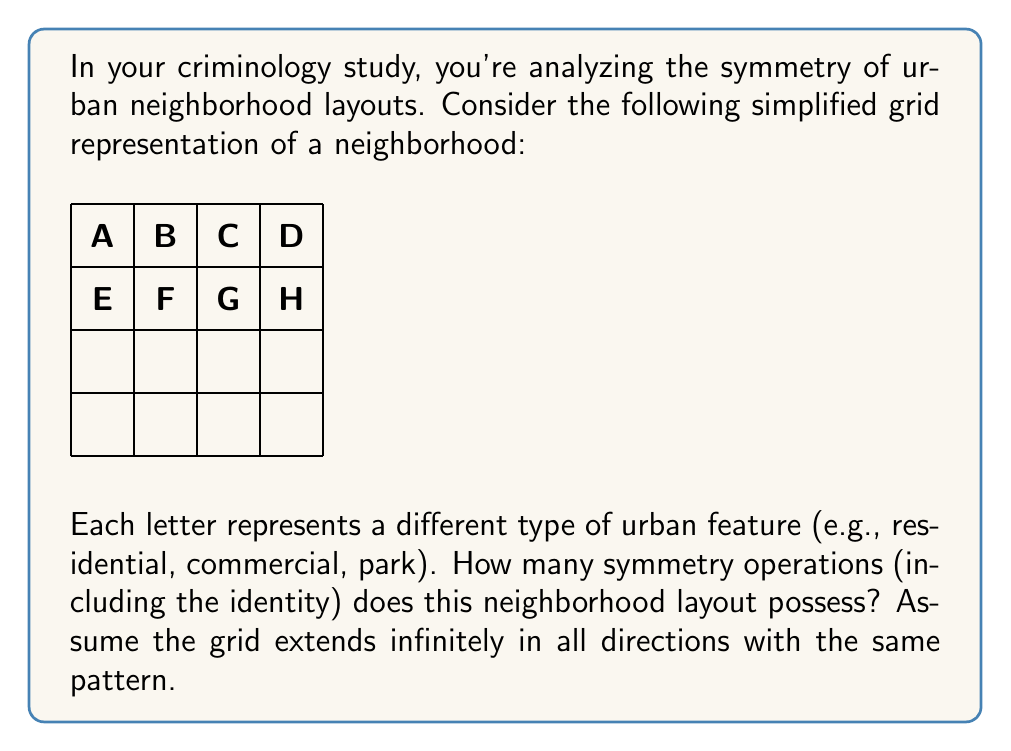Show me your answer to this math problem. To solve this problem, we need to analyze the symmetries of the given pattern. Let's approach this step-by-step:

1) First, identify the basic unit that repeats. In this case, it's a 2x2 grid (ABCD, EFGH).

2) Now, let's consider the possible symmetry operations:

   a) Rotational symmetries:
      - 0° rotation (identity)
      - 180° rotation (half-turn)
      
   b) Reflectional symmetries:
      - Horizontal reflection (across the middle row)
      - Vertical reflection (across the middle column)
      
   c) Translational symmetries:
      - Horizontal translation by 2 units
      - Vertical translation by 2 units
      - Diagonal translation (combination of horizontal and vertical)

3) Let's count these symmetries:
   - 1 identity operation
   - 1 180° rotation
   - 1 horizontal reflection
   - 1 vertical reflection
   - Infinite translational symmetries

4) In group theory, we typically don't count infinite translational symmetries for periodic patterns. Instead, we focus on the symmetries within one repetition of the basic unit.

5) Therefore, the total number of symmetry operations is:
   1 (identity) + 1 (rotation) + 1 (horizontal reflection) + 1 (vertical reflection) = 4

This group of symmetries is isomorphic to the Klein four-group, denoted as $V_4$ or $C_2 \times C_2$.
Answer: 4 